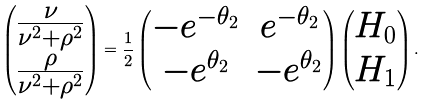Convert formula to latex. <formula><loc_0><loc_0><loc_500><loc_500>\begin{pmatrix} \frac { \nu } { \nu ^ { 2 } + \rho ^ { 2 } } \\ \frac { \rho } { \nu ^ { 2 } + \rho ^ { 2 } } \end{pmatrix} = \frac { 1 } { 2 } \begin{pmatrix} - e ^ { - \theta _ { 2 } } & e ^ { - \theta _ { 2 } } \\ - e ^ { \theta _ { 2 } } & - e ^ { \theta _ { 2 } } \end{pmatrix} \begin{pmatrix} H _ { 0 } \\ H _ { 1 } \end{pmatrix} .</formula> 